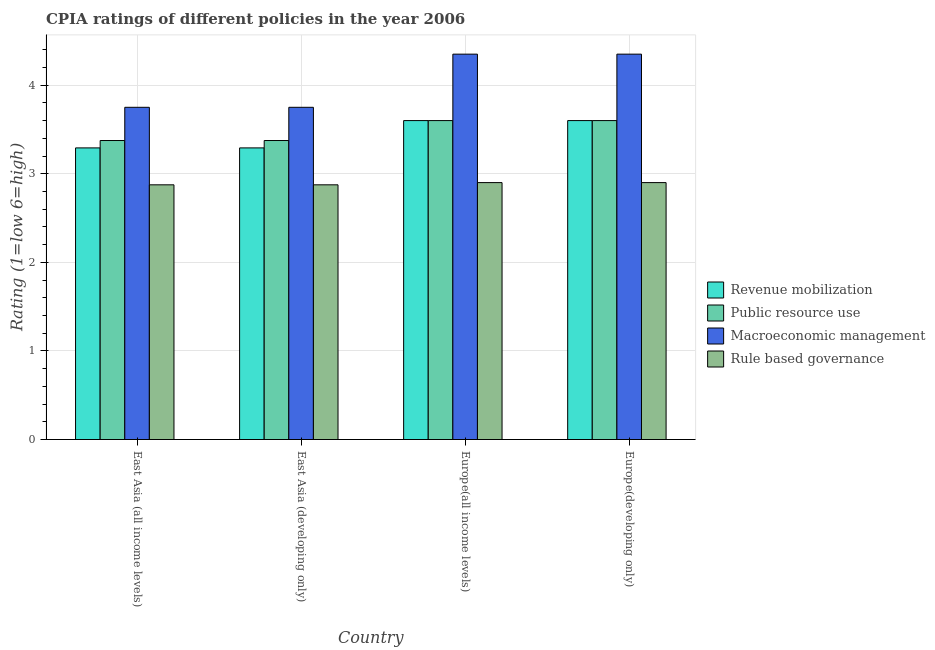How many groups of bars are there?
Keep it short and to the point. 4. How many bars are there on the 1st tick from the left?
Ensure brevity in your answer.  4. How many bars are there on the 3rd tick from the right?
Give a very brief answer. 4. What is the label of the 3rd group of bars from the left?
Provide a succinct answer. Europe(all income levels). In how many cases, is the number of bars for a given country not equal to the number of legend labels?
Your response must be concise. 0. What is the cpia rating of macroeconomic management in Europe(all income levels)?
Your response must be concise. 4.35. Across all countries, what is the minimum cpia rating of revenue mobilization?
Offer a very short reply. 3.29. In which country was the cpia rating of public resource use maximum?
Ensure brevity in your answer.  Europe(all income levels). In which country was the cpia rating of rule based governance minimum?
Make the answer very short. East Asia (all income levels). What is the total cpia rating of public resource use in the graph?
Make the answer very short. 13.95. What is the difference between the cpia rating of public resource use in East Asia (developing only) and that in Europe(all income levels)?
Your answer should be very brief. -0.23. What is the difference between the cpia rating of revenue mobilization in East Asia (developing only) and the cpia rating of macroeconomic management in East Asia (all income levels)?
Your answer should be compact. -0.46. What is the average cpia rating of revenue mobilization per country?
Offer a terse response. 3.45. What is the difference between the cpia rating of macroeconomic management and cpia rating of revenue mobilization in East Asia (all income levels)?
Keep it short and to the point. 0.46. In how many countries, is the cpia rating of revenue mobilization greater than 1.2 ?
Offer a very short reply. 4. What is the difference between the highest and the lowest cpia rating of public resource use?
Give a very brief answer. 0.23. In how many countries, is the cpia rating of public resource use greater than the average cpia rating of public resource use taken over all countries?
Provide a succinct answer. 2. Is it the case that in every country, the sum of the cpia rating of public resource use and cpia rating of rule based governance is greater than the sum of cpia rating of macroeconomic management and cpia rating of revenue mobilization?
Your answer should be very brief. Yes. What does the 4th bar from the left in Europe(developing only) represents?
Give a very brief answer. Rule based governance. What does the 1st bar from the right in East Asia (all income levels) represents?
Your response must be concise. Rule based governance. Is it the case that in every country, the sum of the cpia rating of revenue mobilization and cpia rating of public resource use is greater than the cpia rating of macroeconomic management?
Your answer should be very brief. Yes. How many bars are there?
Give a very brief answer. 16. Are all the bars in the graph horizontal?
Provide a short and direct response. No. How many countries are there in the graph?
Provide a short and direct response. 4. Are the values on the major ticks of Y-axis written in scientific E-notation?
Your answer should be very brief. No. Does the graph contain any zero values?
Make the answer very short. No. Does the graph contain grids?
Keep it short and to the point. Yes. Where does the legend appear in the graph?
Offer a terse response. Center right. How many legend labels are there?
Give a very brief answer. 4. How are the legend labels stacked?
Make the answer very short. Vertical. What is the title of the graph?
Provide a short and direct response. CPIA ratings of different policies in the year 2006. What is the label or title of the X-axis?
Provide a succinct answer. Country. What is the Rating (1=low 6=high) of Revenue mobilization in East Asia (all income levels)?
Provide a short and direct response. 3.29. What is the Rating (1=low 6=high) of Public resource use in East Asia (all income levels)?
Give a very brief answer. 3.38. What is the Rating (1=low 6=high) of Macroeconomic management in East Asia (all income levels)?
Offer a very short reply. 3.75. What is the Rating (1=low 6=high) in Rule based governance in East Asia (all income levels)?
Offer a very short reply. 2.88. What is the Rating (1=low 6=high) of Revenue mobilization in East Asia (developing only)?
Make the answer very short. 3.29. What is the Rating (1=low 6=high) of Public resource use in East Asia (developing only)?
Ensure brevity in your answer.  3.38. What is the Rating (1=low 6=high) of Macroeconomic management in East Asia (developing only)?
Keep it short and to the point. 3.75. What is the Rating (1=low 6=high) in Rule based governance in East Asia (developing only)?
Your answer should be compact. 2.88. What is the Rating (1=low 6=high) in Public resource use in Europe(all income levels)?
Keep it short and to the point. 3.6. What is the Rating (1=low 6=high) of Macroeconomic management in Europe(all income levels)?
Keep it short and to the point. 4.35. What is the Rating (1=low 6=high) in Revenue mobilization in Europe(developing only)?
Your answer should be compact. 3.6. What is the Rating (1=low 6=high) of Macroeconomic management in Europe(developing only)?
Offer a very short reply. 4.35. Across all countries, what is the maximum Rating (1=low 6=high) in Revenue mobilization?
Your response must be concise. 3.6. Across all countries, what is the maximum Rating (1=low 6=high) of Macroeconomic management?
Offer a very short reply. 4.35. Across all countries, what is the minimum Rating (1=low 6=high) of Revenue mobilization?
Your answer should be very brief. 3.29. Across all countries, what is the minimum Rating (1=low 6=high) of Public resource use?
Make the answer very short. 3.38. Across all countries, what is the minimum Rating (1=low 6=high) of Macroeconomic management?
Provide a succinct answer. 3.75. Across all countries, what is the minimum Rating (1=low 6=high) of Rule based governance?
Your answer should be compact. 2.88. What is the total Rating (1=low 6=high) in Revenue mobilization in the graph?
Provide a succinct answer. 13.78. What is the total Rating (1=low 6=high) of Public resource use in the graph?
Provide a succinct answer. 13.95. What is the total Rating (1=low 6=high) of Rule based governance in the graph?
Offer a very short reply. 11.55. What is the difference between the Rating (1=low 6=high) in Public resource use in East Asia (all income levels) and that in East Asia (developing only)?
Offer a very short reply. 0. What is the difference between the Rating (1=low 6=high) of Macroeconomic management in East Asia (all income levels) and that in East Asia (developing only)?
Offer a very short reply. 0. What is the difference between the Rating (1=low 6=high) in Revenue mobilization in East Asia (all income levels) and that in Europe(all income levels)?
Offer a terse response. -0.31. What is the difference between the Rating (1=low 6=high) of Public resource use in East Asia (all income levels) and that in Europe(all income levels)?
Make the answer very short. -0.23. What is the difference between the Rating (1=low 6=high) in Macroeconomic management in East Asia (all income levels) and that in Europe(all income levels)?
Offer a very short reply. -0.6. What is the difference between the Rating (1=low 6=high) of Rule based governance in East Asia (all income levels) and that in Europe(all income levels)?
Ensure brevity in your answer.  -0.03. What is the difference between the Rating (1=low 6=high) of Revenue mobilization in East Asia (all income levels) and that in Europe(developing only)?
Your answer should be very brief. -0.31. What is the difference between the Rating (1=low 6=high) of Public resource use in East Asia (all income levels) and that in Europe(developing only)?
Keep it short and to the point. -0.23. What is the difference between the Rating (1=low 6=high) of Macroeconomic management in East Asia (all income levels) and that in Europe(developing only)?
Offer a terse response. -0.6. What is the difference between the Rating (1=low 6=high) in Rule based governance in East Asia (all income levels) and that in Europe(developing only)?
Offer a terse response. -0.03. What is the difference between the Rating (1=low 6=high) of Revenue mobilization in East Asia (developing only) and that in Europe(all income levels)?
Your answer should be compact. -0.31. What is the difference between the Rating (1=low 6=high) in Public resource use in East Asia (developing only) and that in Europe(all income levels)?
Keep it short and to the point. -0.23. What is the difference between the Rating (1=low 6=high) in Macroeconomic management in East Asia (developing only) and that in Europe(all income levels)?
Provide a short and direct response. -0.6. What is the difference between the Rating (1=low 6=high) of Rule based governance in East Asia (developing only) and that in Europe(all income levels)?
Ensure brevity in your answer.  -0.03. What is the difference between the Rating (1=low 6=high) of Revenue mobilization in East Asia (developing only) and that in Europe(developing only)?
Your answer should be compact. -0.31. What is the difference between the Rating (1=low 6=high) of Public resource use in East Asia (developing only) and that in Europe(developing only)?
Give a very brief answer. -0.23. What is the difference between the Rating (1=low 6=high) in Macroeconomic management in East Asia (developing only) and that in Europe(developing only)?
Give a very brief answer. -0.6. What is the difference between the Rating (1=low 6=high) in Rule based governance in East Asia (developing only) and that in Europe(developing only)?
Ensure brevity in your answer.  -0.03. What is the difference between the Rating (1=low 6=high) of Revenue mobilization in Europe(all income levels) and that in Europe(developing only)?
Your answer should be compact. 0. What is the difference between the Rating (1=low 6=high) of Public resource use in Europe(all income levels) and that in Europe(developing only)?
Give a very brief answer. 0. What is the difference between the Rating (1=low 6=high) in Revenue mobilization in East Asia (all income levels) and the Rating (1=low 6=high) in Public resource use in East Asia (developing only)?
Give a very brief answer. -0.08. What is the difference between the Rating (1=low 6=high) in Revenue mobilization in East Asia (all income levels) and the Rating (1=low 6=high) in Macroeconomic management in East Asia (developing only)?
Provide a short and direct response. -0.46. What is the difference between the Rating (1=low 6=high) of Revenue mobilization in East Asia (all income levels) and the Rating (1=low 6=high) of Rule based governance in East Asia (developing only)?
Offer a terse response. 0.42. What is the difference between the Rating (1=low 6=high) of Public resource use in East Asia (all income levels) and the Rating (1=low 6=high) of Macroeconomic management in East Asia (developing only)?
Give a very brief answer. -0.38. What is the difference between the Rating (1=low 6=high) of Macroeconomic management in East Asia (all income levels) and the Rating (1=low 6=high) of Rule based governance in East Asia (developing only)?
Ensure brevity in your answer.  0.88. What is the difference between the Rating (1=low 6=high) in Revenue mobilization in East Asia (all income levels) and the Rating (1=low 6=high) in Public resource use in Europe(all income levels)?
Your answer should be very brief. -0.31. What is the difference between the Rating (1=low 6=high) in Revenue mobilization in East Asia (all income levels) and the Rating (1=low 6=high) in Macroeconomic management in Europe(all income levels)?
Give a very brief answer. -1.06. What is the difference between the Rating (1=low 6=high) in Revenue mobilization in East Asia (all income levels) and the Rating (1=low 6=high) in Rule based governance in Europe(all income levels)?
Your answer should be compact. 0.39. What is the difference between the Rating (1=low 6=high) in Public resource use in East Asia (all income levels) and the Rating (1=low 6=high) in Macroeconomic management in Europe(all income levels)?
Your response must be concise. -0.97. What is the difference between the Rating (1=low 6=high) of Public resource use in East Asia (all income levels) and the Rating (1=low 6=high) of Rule based governance in Europe(all income levels)?
Offer a terse response. 0.47. What is the difference between the Rating (1=low 6=high) of Macroeconomic management in East Asia (all income levels) and the Rating (1=low 6=high) of Rule based governance in Europe(all income levels)?
Give a very brief answer. 0.85. What is the difference between the Rating (1=low 6=high) of Revenue mobilization in East Asia (all income levels) and the Rating (1=low 6=high) of Public resource use in Europe(developing only)?
Offer a very short reply. -0.31. What is the difference between the Rating (1=low 6=high) in Revenue mobilization in East Asia (all income levels) and the Rating (1=low 6=high) in Macroeconomic management in Europe(developing only)?
Your answer should be very brief. -1.06. What is the difference between the Rating (1=low 6=high) in Revenue mobilization in East Asia (all income levels) and the Rating (1=low 6=high) in Rule based governance in Europe(developing only)?
Give a very brief answer. 0.39. What is the difference between the Rating (1=low 6=high) of Public resource use in East Asia (all income levels) and the Rating (1=low 6=high) of Macroeconomic management in Europe(developing only)?
Your answer should be very brief. -0.97. What is the difference between the Rating (1=low 6=high) in Public resource use in East Asia (all income levels) and the Rating (1=low 6=high) in Rule based governance in Europe(developing only)?
Offer a very short reply. 0.47. What is the difference between the Rating (1=low 6=high) in Macroeconomic management in East Asia (all income levels) and the Rating (1=low 6=high) in Rule based governance in Europe(developing only)?
Your answer should be very brief. 0.85. What is the difference between the Rating (1=low 6=high) in Revenue mobilization in East Asia (developing only) and the Rating (1=low 6=high) in Public resource use in Europe(all income levels)?
Provide a succinct answer. -0.31. What is the difference between the Rating (1=low 6=high) in Revenue mobilization in East Asia (developing only) and the Rating (1=low 6=high) in Macroeconomic management in Europe(all income levels)?
Give a very brief answer. -1.06. What is the difference between the Rating (1=low 6=high) of Revenue mobilization in East Asia (developing only) and the Rating (1=low 6=high) of Rule based governance in Europe(all income levels)?
Offer a terse response. 0.39. What is the difference between the Rating (1=low 6=high) in Public resource use in East Asia (developing only) and the Rating (1=low 6=high) in Macroeconomic management in Europe(all income levels)?
Your response must be concise. -0.97. What is the difference between the Rating (1=low 6=high) of Public resource use in East Asia (developing only) and the Rating (1=low 6=high) of Rule based governance in Europe(all income levels)?
Your answer should be very brief. 0.47. What is the difference between the Rating (1=low 6=high) in Revenue mobilization in East Asia (developing only) and the Rating (1=low 6=high) in Public resource use in Europe(developing only)?
Your answer should be compact. -0.31. What is the difference between the Rating (1=low 6=high) of Revenue mobilization in East Asia (developing only) and the Rating (1=low 6=high) of Macroeconomic management in Europe(developing only)?
Provide a succinct answer. -1.06. What is the difference between the Rating (1=low 6=high) in Revenue mobilization in East Asia (developing only) and the Rating (1=low 6=high) in Rule based governance in Europe(developing only)?
Your answer should be compact. 0.39. What is the difference between the Rating (1=low 6=high) in Public resource use in East Asia (developing only) and the Rating (1=low 6=high) in Macroeconomic management in Europe(developing only)?
Ensure brevity in your answer.  -0.97. What is the difference between the Rating (1=low 6=high) of Public resource use in East Asia (developing only) and the Rating (1=low 6=high) of Rule based governance in Europe(developing only)?
Offer a very short reply. 0.47. What is the difference between the Rating (1=low 6=high) in Macroeconomic management in East Asia (developing only) and the Rating (1=low 6=high) in Rule based governance in Europe(developing only)?
Keep it short and to the point. 0.85. What is the difference between the Rating (1=low 6=high) in Revenue mobilization in Europe(all income levels) and the Rating (1=low 6=high) in Macroeconomic management in Europe(developing only)?
Provide a succinct answer. -0.75. What is the difference between the Rating (1=low 6=high) in Revenue mobilization in Europe(all income levels) and the Rating (1=low 6=high) in Rule based governance in Europe(developing only)?
Provide a short and direct response. 0.7. What is the difference between the Rating (1=low 6=high) in Public resource use in Europe(all income levels) and the Rating (1=low 6=high) in Macroeconomic management in Europe(developing only)?
Ensure brevity in your answer.  -0.75. What is the difference between the Rating (1=low 6=high) in Public resource use in Europe(all income levels) and the Rating (1=low 6=high) in Rule based governance in Europe(developing only)?
Your answer should be very brief. 0.7. What is the difference between the Rating (1=low 6=high) in Macroeconomic management in Europe(all income levels) and the Rating (1=low 6=high) in Rule based governance in Europe(developing only)?
Ensure brevity in your answer.  1.45. What is the average Rating (1=low 6=high) in Revenue mobilization per country?
Ensure brevity in your answer.  3.45. What is the average Rating (1=low 6=high) of Public resource use per country?
Your response must be concise. 3.49. What is the average Rating (1=low 6=high) of Macroeconomic management per country?
Provide a succinct answer. 4.05. What is the average Rating (1=low 6=high) in Rule based governance per country?
Make the answer very short. 2.89. What is the difference between the Rating (1=low 6=high) of Revenue mobilization and Rating (1=low 6=high) of Public resource use in East Asia (all income levels)?
Ensure brevity in your answer.  -0.08. What is the difference between the Rating (1=low 6=high) of Revenue mobilization and Rating (1=low 6=high) of Macroeconomic management in East Asia (all income levels)?
Offer a terse response. -0.46. What is the difference between the Rating (1=low 6=high) in Revenue mobilization and Rating (1=low 6=high) in Rule based governance in East Asia (all income levels)?
Provide a short and direct response. 0.42. What is the difference between the Rating (1=low 6=high) of Public resource use and Rating (1=low 6=high) of Macroeconomic management in East Asia (all income levels)?
Give a very brief answer. -0.38. What is the difference between the Rating (1=low 6=high) in Macroeconomic management and Rating (1=low 6=high) in Rule based governance in East Asia (all income levels)?
Your answer should be very brief. 0.88. What is the difference between the Rating (1=low 6=high) of Revenue mobilization and Rating (1=low 6=high) of Public resource use in East Asia (developing only)?
Your answer should be compact. -0.08. What is the difference between the Rating (1=low 6=high) of Revenue mobilization and Rating (1=low 6=high) of Macroeconomic management in East Asia (developing only)?
Your response must be concise. -0.46. What is the difference between the Rating (1=low 6=high) in Revenue mobilization and Rating (1=low 6=high) in Rule based governance in East Asia (developing only)?
Provide a short and direct response. 0.42. What is the difference between the Rating (1=low 6=high) in Public resource use and Rating (1=low 6=high) in Macroeconomic management in East Asia (developing only)?
Offer a terse response. -0.38. What is the difference between the Rating (1=low 6=high) of Revenue mobilization and Rating (1=low 6=high) of Macroeconomic management in Europe(all income levels)?
Ensure brevity in your answer.  -0.75. What is the difference between the Rating (1=low 6=high) in Public resource use and Rating (1=low 6=high) in Macroeconomic management in Europe(all income levels)?
Offer a terse response. -0.75. What is the difference between the Rating (1=low 6=high) in Public resource use and Rating (1=low 6=high) in Rule based governance in Europe(all income levels)?
Keep it short and to the point. 0.7. What is the difference between the Rating (1=low 6=high) in Macroeconomic management and Rating (1=low 6=high) in Rule based governance in Europe(all income levels)?
Your answer should be very brief. 1.45. What is the difference between the Rating (1=low 6=high) of Revenue mobilization and Rating (1=low 6=high) of Public resource use in Europe(developing only)?
Offer a very short reply. 0. What is the difference between the Rating (1=low 6=high) of Revenue mobilization and Rating (1=low 6=high) of Macroeconomic management in Europe(developing only)?
Offer a terse response. -0.75. What is the difference between the Rating (1=low 6=high) in Revenue mobilization and Rating (1=low 6=high) in Rule based governance in Europe(developing only)?
Ensure brevity in your answer.  0.7. What is the difference between the Rating (1=low 6=high) in Public resource use and Rating (1=low 6=high) in Macroeconomic management in Europe(developing only)?
Offer a terse response. -0.75. What is the difference between the Rating (1=low 6=high) in Public resource use and Rating (1=low 6=high) in Rule based governance in Europe(developing only)?
Offer a terse response. 0.7. What is the difference between the Rating (1=low 6=high) of Macroeconomic management and Rating (1=low 6=high) of Rule based governance in Europe(developing only)?
Your answer should be very brief. 1.45. What is the ratio of the Rating (1=low 6=high) in Public resource use in East Asia (all income levels) to that in East Asia (developing only)?
Your answer should be very brief. 1. What is the ratio of the Rating (1=low 6=high) in Macroeconomic management in East Asia (all income levels) to that in East Asia (developing only)?
Offer a terse response. 1. What is the ratio of the Rating (1=low 6=high) of Rule based governance in East Asia (all income levels) to that in East Asia (developing only)?
Your answer should be compact. 1. What is the ratio of the Rating (1=low 6=high) in Revenue mobilization in East Asia (all income levels) to that in Europe(all income levels)?
Offer a terse response. 0.91. What is the ratio of the Rating (1=low 6=high) of Macroeconomic management in East Asia (all income levels) to that in Europe(all income levels)?
Your answer should be compact. 0.86. What is the ratio of the Rating (1=low 6=high) of Revenue mobilization in East Asia (all income levels) to that in Europe(developing only)?
Offer a terse response. 0.91. What is the ratio of the Rating (1=low 6=high) of Macroeconomic management in East Asia (all income levels) to that in Europe(developing only)?
Your answer should be compact. 0.86. What is the ratio of the Rating (1=low 6=high) in Revenue mobilization in East Asia (developing only) to that in Europe(all income levels)?
Provide a succinct answer. 0.91. What is the ratio of the Rating (1=low 6=high) of Macroeconomic management in East Asia (developing only) to that in Europe(all income levels)?
Give a very brief answer. 0.86. What is the ratio of the Rating (1=low 6=high) in Revenue mobilization in East Asia (developing only) to that in Europe(developing only)?
Provide a short and direct response. 0.91. What is the ratio of the Rating (1=low 6=high) of Macroeconomic management in East Asia (developing only) to that in Europe(developing only)?
Make the answer very short. 0.86. What is the ratio of the Rating (1=low 6=high) in Public resource use in Europe(all income levels) to that in Europe(developing only)?
Provide a short and direct response. 1. What is the ratio of the Rating (1=low 6=high) of Macroeconomic management in Europe(all income levels) to that in Europe(developing only)?
Your answer should be very brief. 1. What is the difference between the highest and the second highest Rating (1=low 6=high) in Revenue mobilization?
Keep it short and to the point. 0. What is the difference between the highest and the second highest Rating (1=low 6=high) in Rule based governance?
Your answer should be compact. 0. What is the difference between the highest and the lowest Rating (1=low 6=high) of Revenue mobilization?
Offer a terse response. 0.31. What is the difference between the highest and the lowest Rating (1=low 6=high) of Public resource use?
Provide a succinct answer. 0.23. What is the difference between the highest and the lowest Rating (1=low 6=high) of Macroeconomic management?
Offer a very short reply. 0.6. What is the difference between the highest and the lowest Rating (1=low 6=high) in Rule based governance?
Provide a short and direct response. 0.03. 